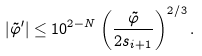Convert formula to latex. <formula><loc_0><loc_0><loc_500><loc_500>| \tilde { \varphi } ^ { \prime } | \leq 1 0 ^ { 2 - N } \left ( \frac { \tilde { \varphi } } { 2 s _ { i + 1 } } \right ) ^ { 2 / 3 } .</formula> 